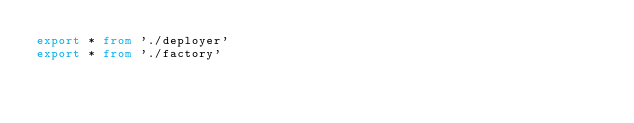Convert code to text. <code><loc_0><loc_0><loc_500><loc_500><_TypeScript_>export * from './deployer'
export * from './factory'</code> 